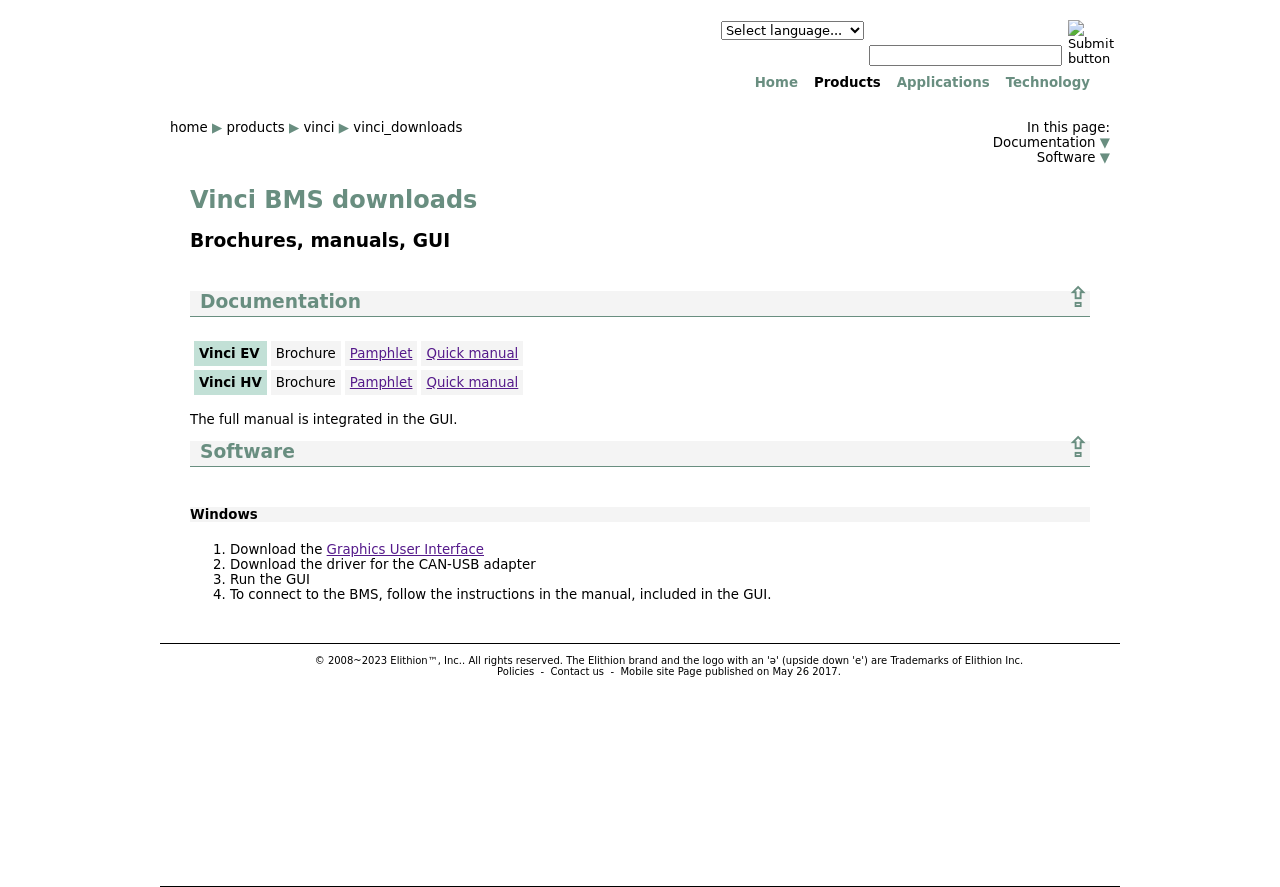How can I translate the text on this website to another language? To translate text on the website, you can use the language selector dropdown visible in the site's header. Choose your desired language from the dropdown, and the site should be translated automatically.  Is there a mobile version of this site available? According to the footer of the website, there is mention of a mobile site. You would typically find a link to the mobile version in the footer or header, or the website may automatically redirect you to the mobile version if you're on a handheld device. 